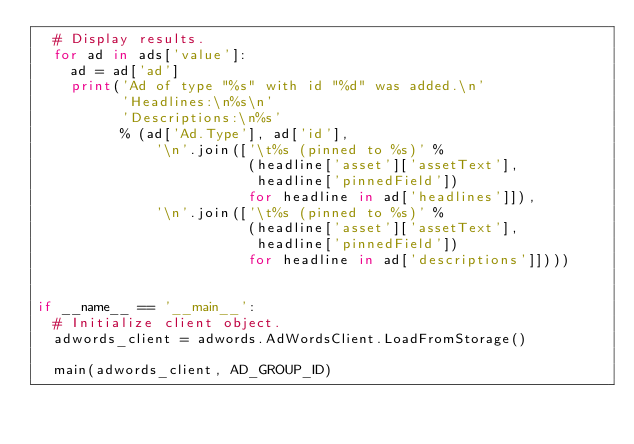<code> <loc_0><loc_0><loc_500><loc_500><_Python_>  # Display results.
  for ad in ads['value']:
    ad = ad['ad']
    print('Ad of type "%s" with id "%d" was added.\n'
          'Headlines:\n%s\n'
          'Descriptions:\n%s'
          % (ad['Ad.Type'], ad['id'],
              '\n'.join(['\t%s (pinned to %s)' %
                         (headline['asset']['assetText'],
                          headline['pinnedField'])
                         for headline in ad['headlines']]),
              '\n'.join(['\t%s (pinned to %s)' %
                         (headline['asset']['assetText'],
                          headline['pinnedField'])
                         for headline in ad['descriptions']])))


if __name__ == '__main__':
  # Initialize client object.
  adwords_client = adwords.AdWordsClient.LoadFromStorage()

  main(adwords_client, AD_GROUP_ID)
</code> 